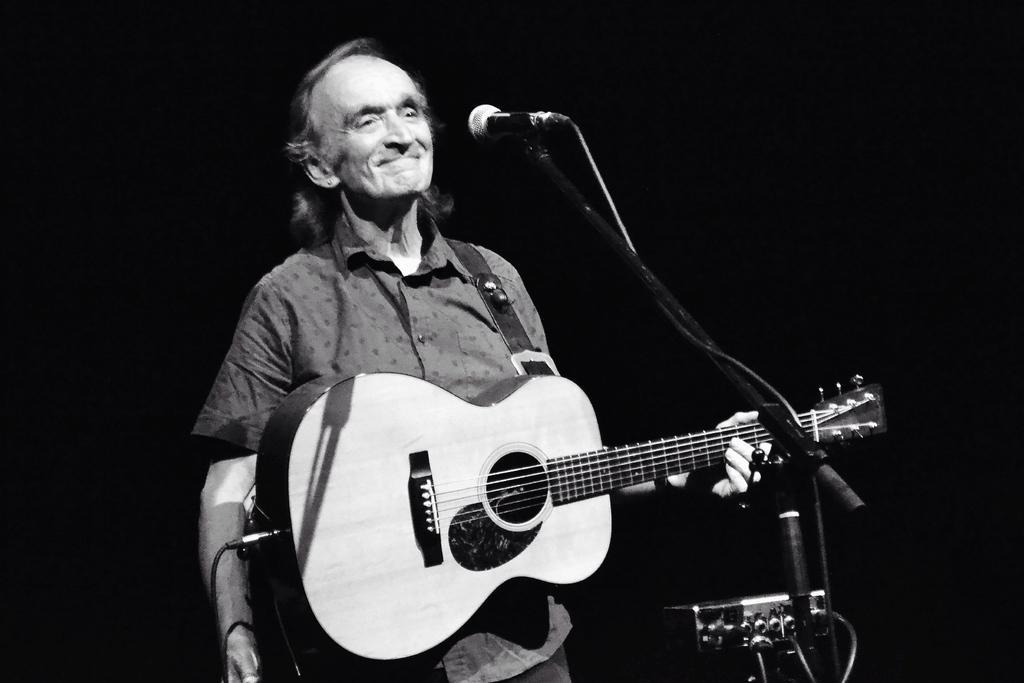How would you summarize this image in a sentence or two? This picture shows a man holding a guitar and smiling, standing in front of a microphone and a stand here. There is dark in the background. 